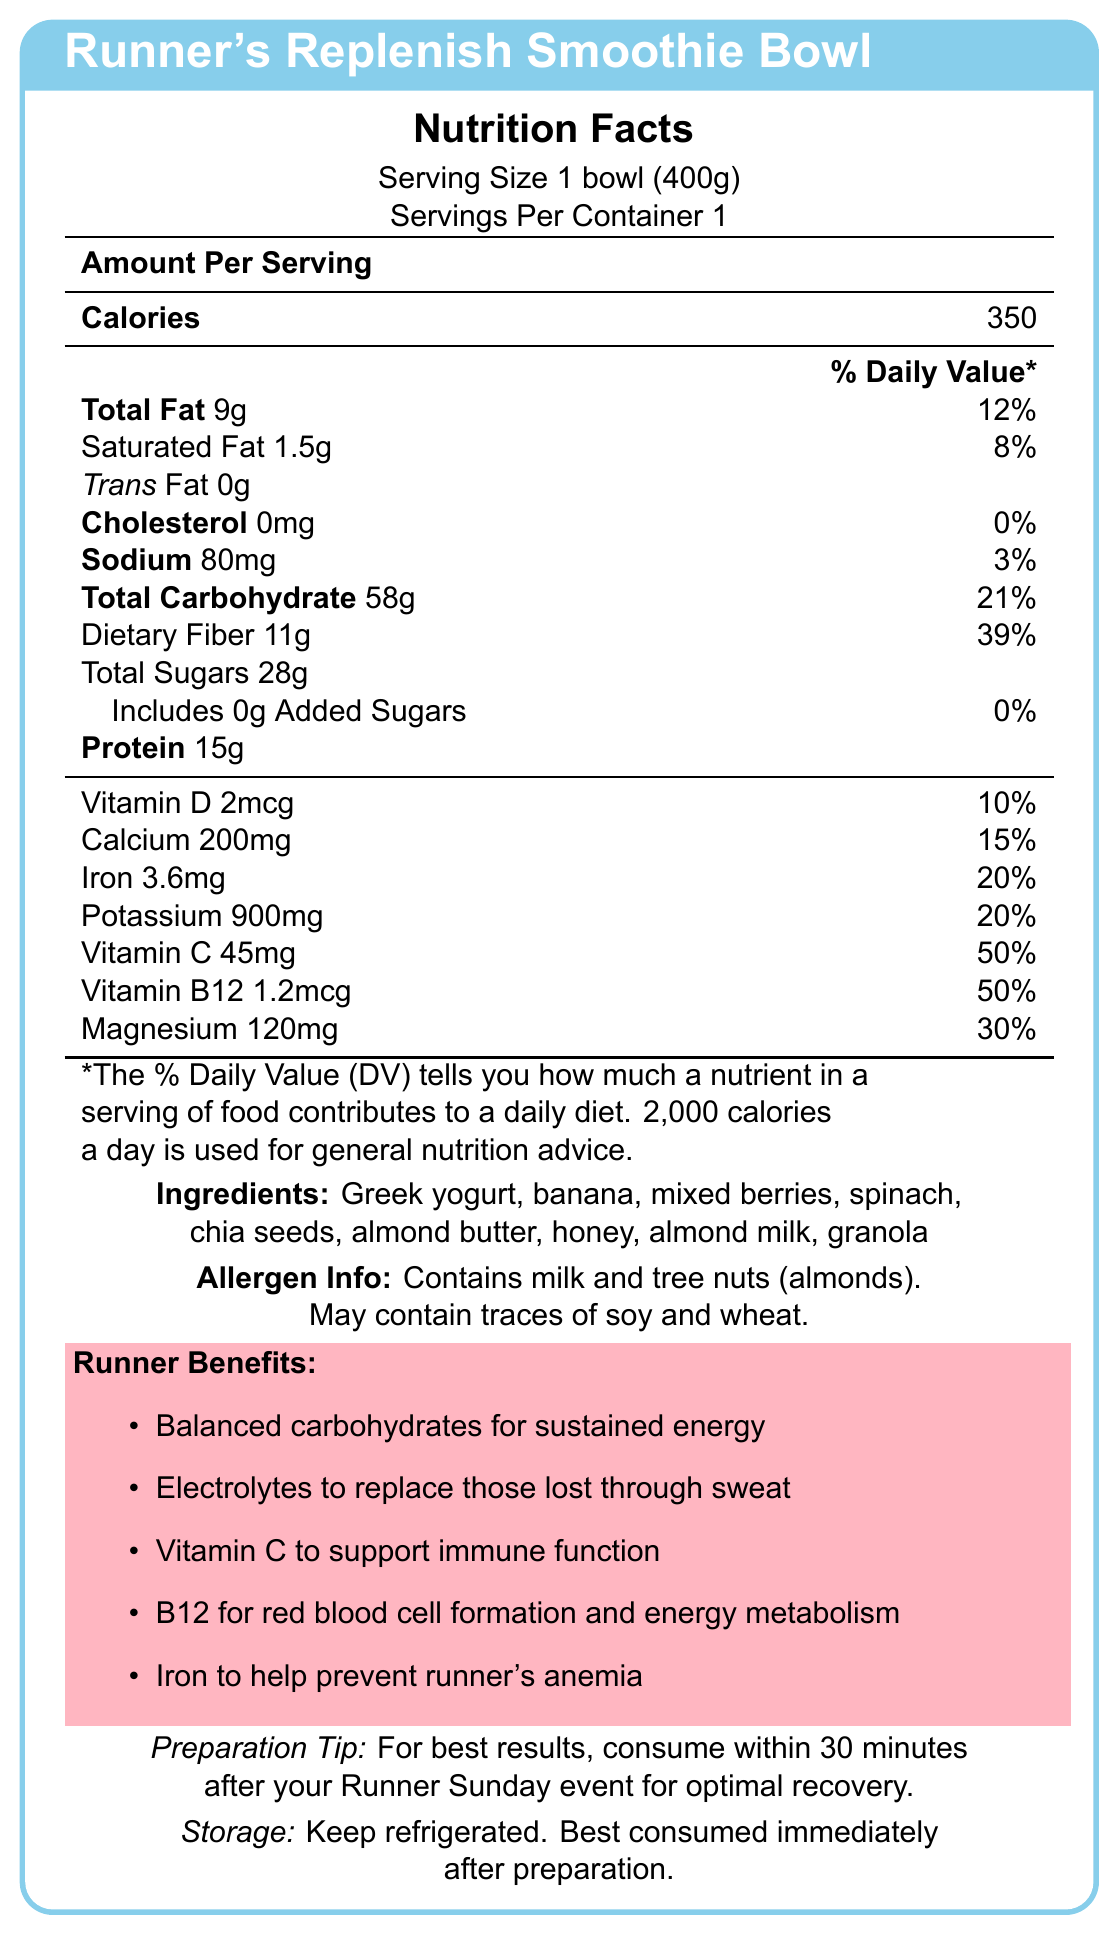what is the serving size of the Runner's Replenish Smoothie Bowl? According to the document, the serving size is listed as 1 bowl (400g).
Answer: 1 bowl (400g) how many calories are in one serving? The document states that the amount per serving is 350 calories.
Answer: 350 calories what are the main ingredients in the smoothie bowl? The ingredients listed in the document are: Greek yogurt, banana, mixed berries, spinach, chia seeds, almond butter, honey, almond milk, and granola.
Answer: Greek yogurt, banana, mixed berries, spinach, chia seeds, almond butter, honey, almond milk, granola how much protein does one serving contain? The document indicates that one serving contains 15g of protein.
Answer: 15g what is the percentage of daily value for dietary fiber? According to the document, the daily value percentage for dietary fiber is 39%.
Answer: 39% is this smoothie bowl suitable for someone with a peanut allergy? The document mentions that the smoothie bowl contains milk and tree nuts (almonds) but does not mention peanuts. However, it may contain traces of soy and wheat.
Answer: Yes is there any added sugar in the smoothie bowl? The document states that the total added sugars amount to 0g.
Answer: No can the preparation tip help optimize my recovery after a run? The preparation tip specifically suggests consuming the smoothie bowl within 30 minutes after your Runner Sunday event for optimal recovery.
Answer: Yes describe the main purpose of the document. The document is designed to inform consumers, especially runners, about the nutritional content and health benefits of the smoothie bowl, emphasizing its role in recovery and suitable consumption times.
Answer: The document provides detailed nutritional information about the "Runner's Replenish Smoothie Bowl", including its ingredients, allergen information, health claims, benefits specifically relevant to runners, and preparation tips to optimize post-run recovery. how should the smoothie bowl be stored? The storage instructions in the document recommend keeping the smoothie bowl refrigerated and consuming it immediately after preparation.
Answer: Keep refrigerated. Best consumed immediately after preparation. what is the percentage of daily value for magnesium? The document states that the daily value percentage for magnesium is 30%.
Answer: 30% does the smoothie bowl contain soy? The allergen information specifies that the product may contain traces of soy, but it does not confirm whether it definitively contains soy or not.
Answer: Cannot be determined what are the runner benefits listed for this smoothie bowl? These benefits are specifically outlined under the "Runner Benefits" section in the document.
Answer: The runner benefits include balanced carbohydrates for sustained energy, electrolytes to replace those lost through sweat, Vitamin C to support immune function, B12 for red blood cell formation and energy metabolism, and Iron to help prevent runner's anemia. 